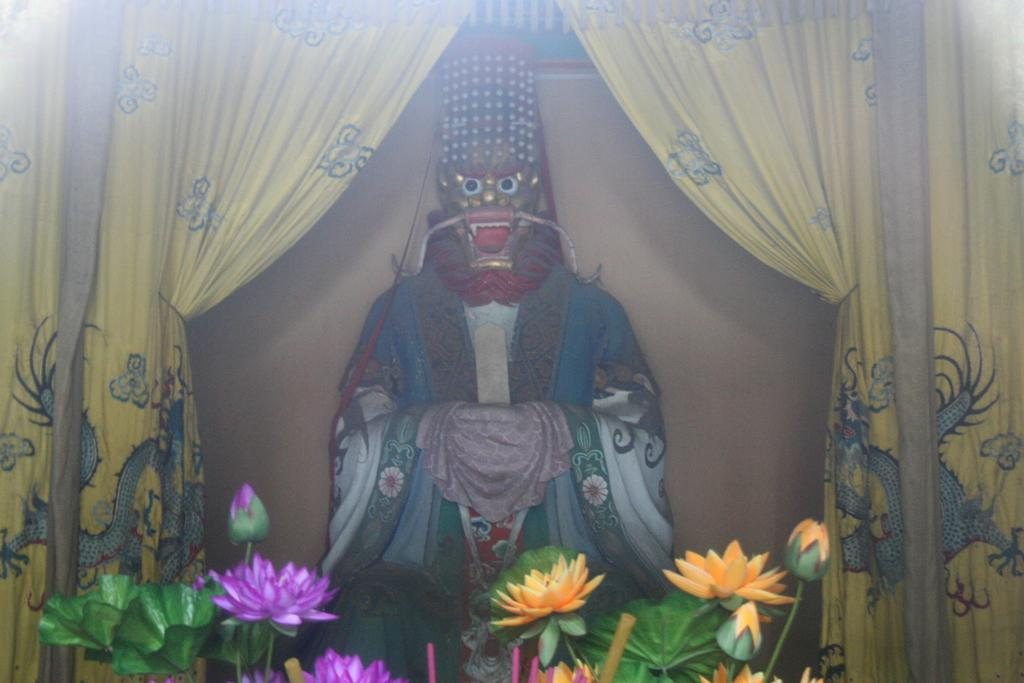What is the main subject in the center of the image? There is a sculpture in the center of the image. What else can be seen in the image besides the sculpture? There is a curtain and flowers visible in the image. Where are the flowers located in the image? The flowers are visible at the bottom of the image. How many legs are visible on the jar in the image? There is no jar present in the image, and therefore no legs can be observed. 